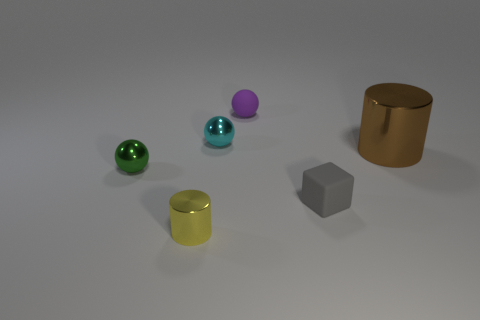There is a tiny yellow metal object in front of the brown thing; what shape is it?
Give a very brief answer. Cylinder. How many things are either rubber objects or yellow cylinders?
Your answer should be very brief. 3. Is the size of the brown metallic cylinder the same as the metallic object in front of the tiny block?
Make the answer very short. No. What number of other things are there of the same material as the large brown object
Ensure brevity in your answer.  3. How many objects are metal objects right of the yellow cylinder or balls behind the tiny cyan sphere?
Give a very brief answer. 3. There is a large brown thing that is the same shape as the small yellow shiny thing; what material is it?
Provide a short and direct response. Metal. Are any tiny matte things visible?
Your answer should be compact. Yes. There is a metal thing that is on the right side of the yellow metal thing and in front of the small cyan shiny ball; what is its size?
Provide a succinct answer. Large. The small green thing has what shape?
Keep it short and to the point. Sphere. Are there any rubber things that are right of the large cylinder behind the tiny yellow object?
Provide a short and direct response. No. 